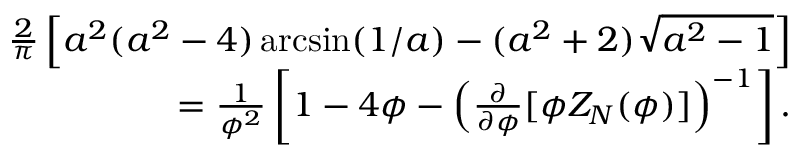<formula> <loc_0><loc_0><loc_500><loc_500>\begin{array} { r } { \frac { 2 } { \pi } \left [ a ^ { 2 } ( a ^ { 2 } - 4 ) \arcsin ( 1 / a ) - ( a ^ { 2 } + 2 ) \sqrt { a ^ { 2 } - 1 } \right ] } \\ { = \frac { 1 } { \phi ^ { 2 } } \left [ 1 - 4 \phi - \left ( \frac { \partial } { \partial \phi } [ \phi Z _ { N } ( \phi ) ] \right ) ^ { - 1 } \right ] . } \end{array}</formula> 